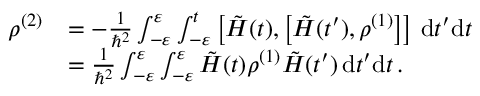<formula> <loc_0><loc_0><loc_500><loc_500>\begin{array} { r l } { \rho ^ { ( 2 ) } } & { = - \frac { 1 } { \hbar { ^ } { 2 } } \int _ { - \varepsilon } ^ { \varepsilon } \int _ { - \varepsilon } ^ { t } \left [ \tilde { H } ( t ) , \left [ \tilde { H } ( t ^ { \prime } ) , \rho ^ { ( 1 ) } \right ] \right ] \, d t ^ { \prime } d t } \\ & { = \frac { 1 } { \hbar { ^ } { 2 } } \int _ { - \varepsilon } ^ { \varepsilon } \int _ { - \varepsilon } ^ { \varepsilon } \tilde { H } ( t ) \rho ^ { ( 1 ) } \tilde { H } ( t ^ { \prime } ) \, d t ^ { \prime } d t \, . } \end{array}</formula> 